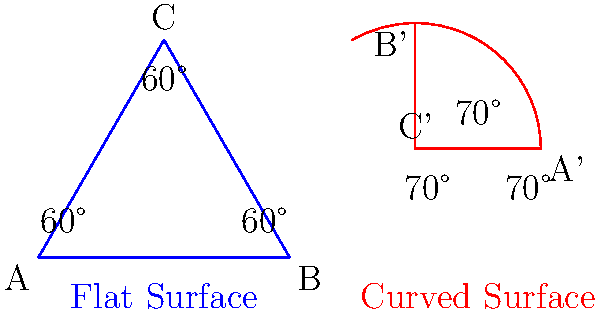Your son is designing a new video game map and shows you two triangular areas: one on a flat surface and another on a curved surface. He explains that the flat triangle has three 60° angles, while the curved triangle has three 70° angles. What's the main difference between these two triangles that allows for this change in angle measurements? Let's break this down step-by-step:

1. In traditional (Euclidean) geometry on a flat surface:
   - The sum of angles in a triangle is always 180°.
   - In the flat blue triangle, we see three 60° angles: $60° + 60° + 60° = 180°$

2. On a curved surface (non-Euclidean geometry):
   - The sum of angles in a triangle can be more than 180°.
   - In the curved red triangle, we see three 70° angles: $70° + 70° + 70° = 210°$

3. The key difference is the surface they're on:
   - Flat surface follows Euclidean geometry rules.
   - Curved surface follows non-Euclidean geometry rules.

4. In video game design:
   - Curved surfaces can create interesting gameplay areas.
   - They allow for unique map designs that aren't possible in real, flat spaces.

5. The main reason for this difference:
   - On a curved surface, parallel lines can intersect.
   - This changes how angles behave and allows for triangles with angle sums greater than 180°.

Therefore, the curved surface's geometry allows for triangles with larger angle sums, which isn't possible on a flat surface.
Answer: The curved surface allows for non-Euclidean geometry, where the sum of a triangle's angles can exceed 180°. 